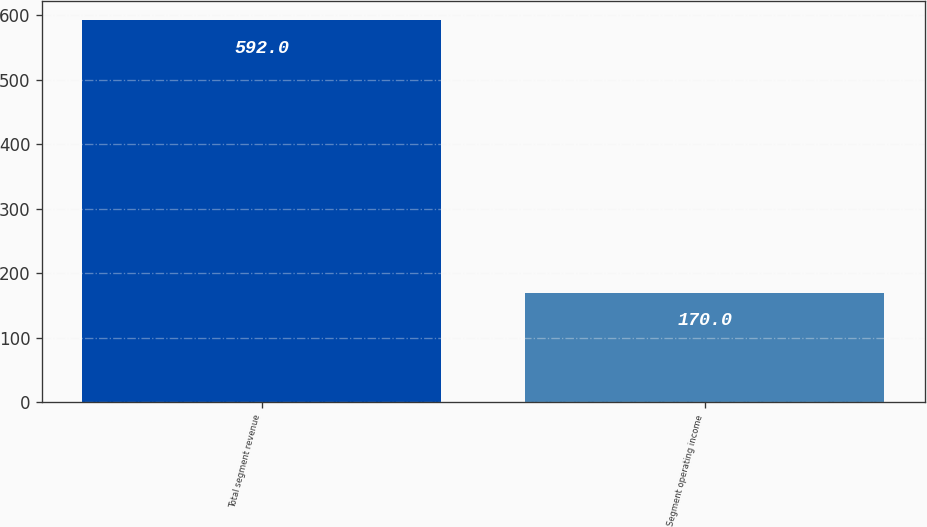Convert chart. <chart><loc_0><loc_0><loc_500><loc_500><bar_chart><fcel>Total segment revenue<fcel>Segment operating income<nl><fcel>592<fcel>170<nl></chart> 